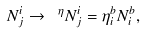<formula> <loc_0><loc_0><loc_500><loc_500>N _ { j } ^ { i } \rightarrow \ ^ { \eta } N _ { j } ^ { i } = \eta _ { i } ^ { b } N _ { i } ^ { b } ,</formula> 